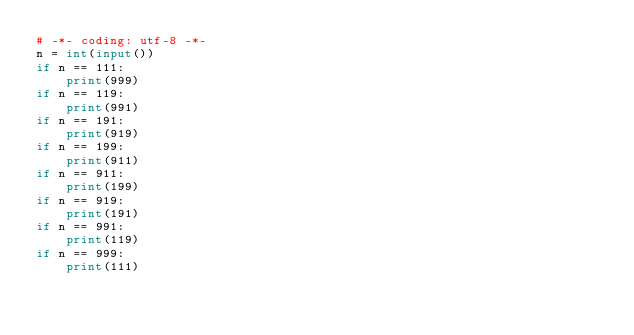Convert code to text. <code><loc_0><loc_0><loc_500><loc_500><_Python_># -*- coding: utf-8 -*-
n = int(input())
if n == 111:
    print(999)
if n == 119:
    print(991)
if n == 191:
    print(919)
if n == 199:
    print(911)
if n == 911:
    print(199)
if n == 919:
    print(191)
if n == 991:
    print(119)
if n == 999:
    print(111)
</code> 